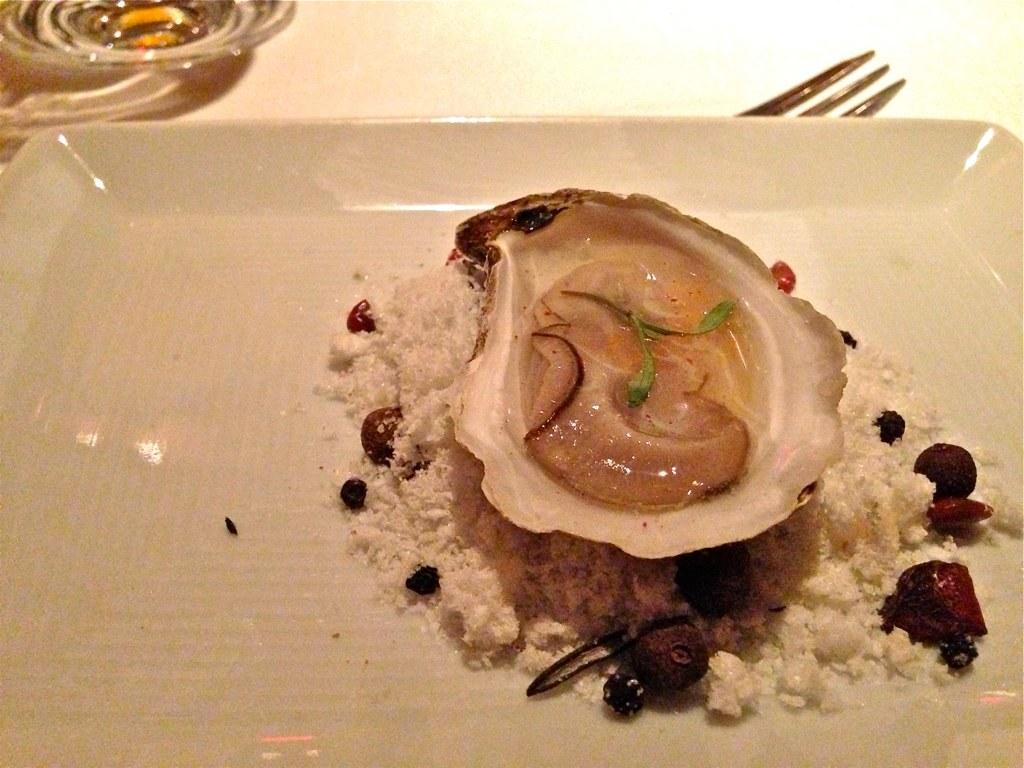How would you summarize this image in a sentence or two? This image consists of an oyster. It is kept in a tray. And we can see a fork in this image. 